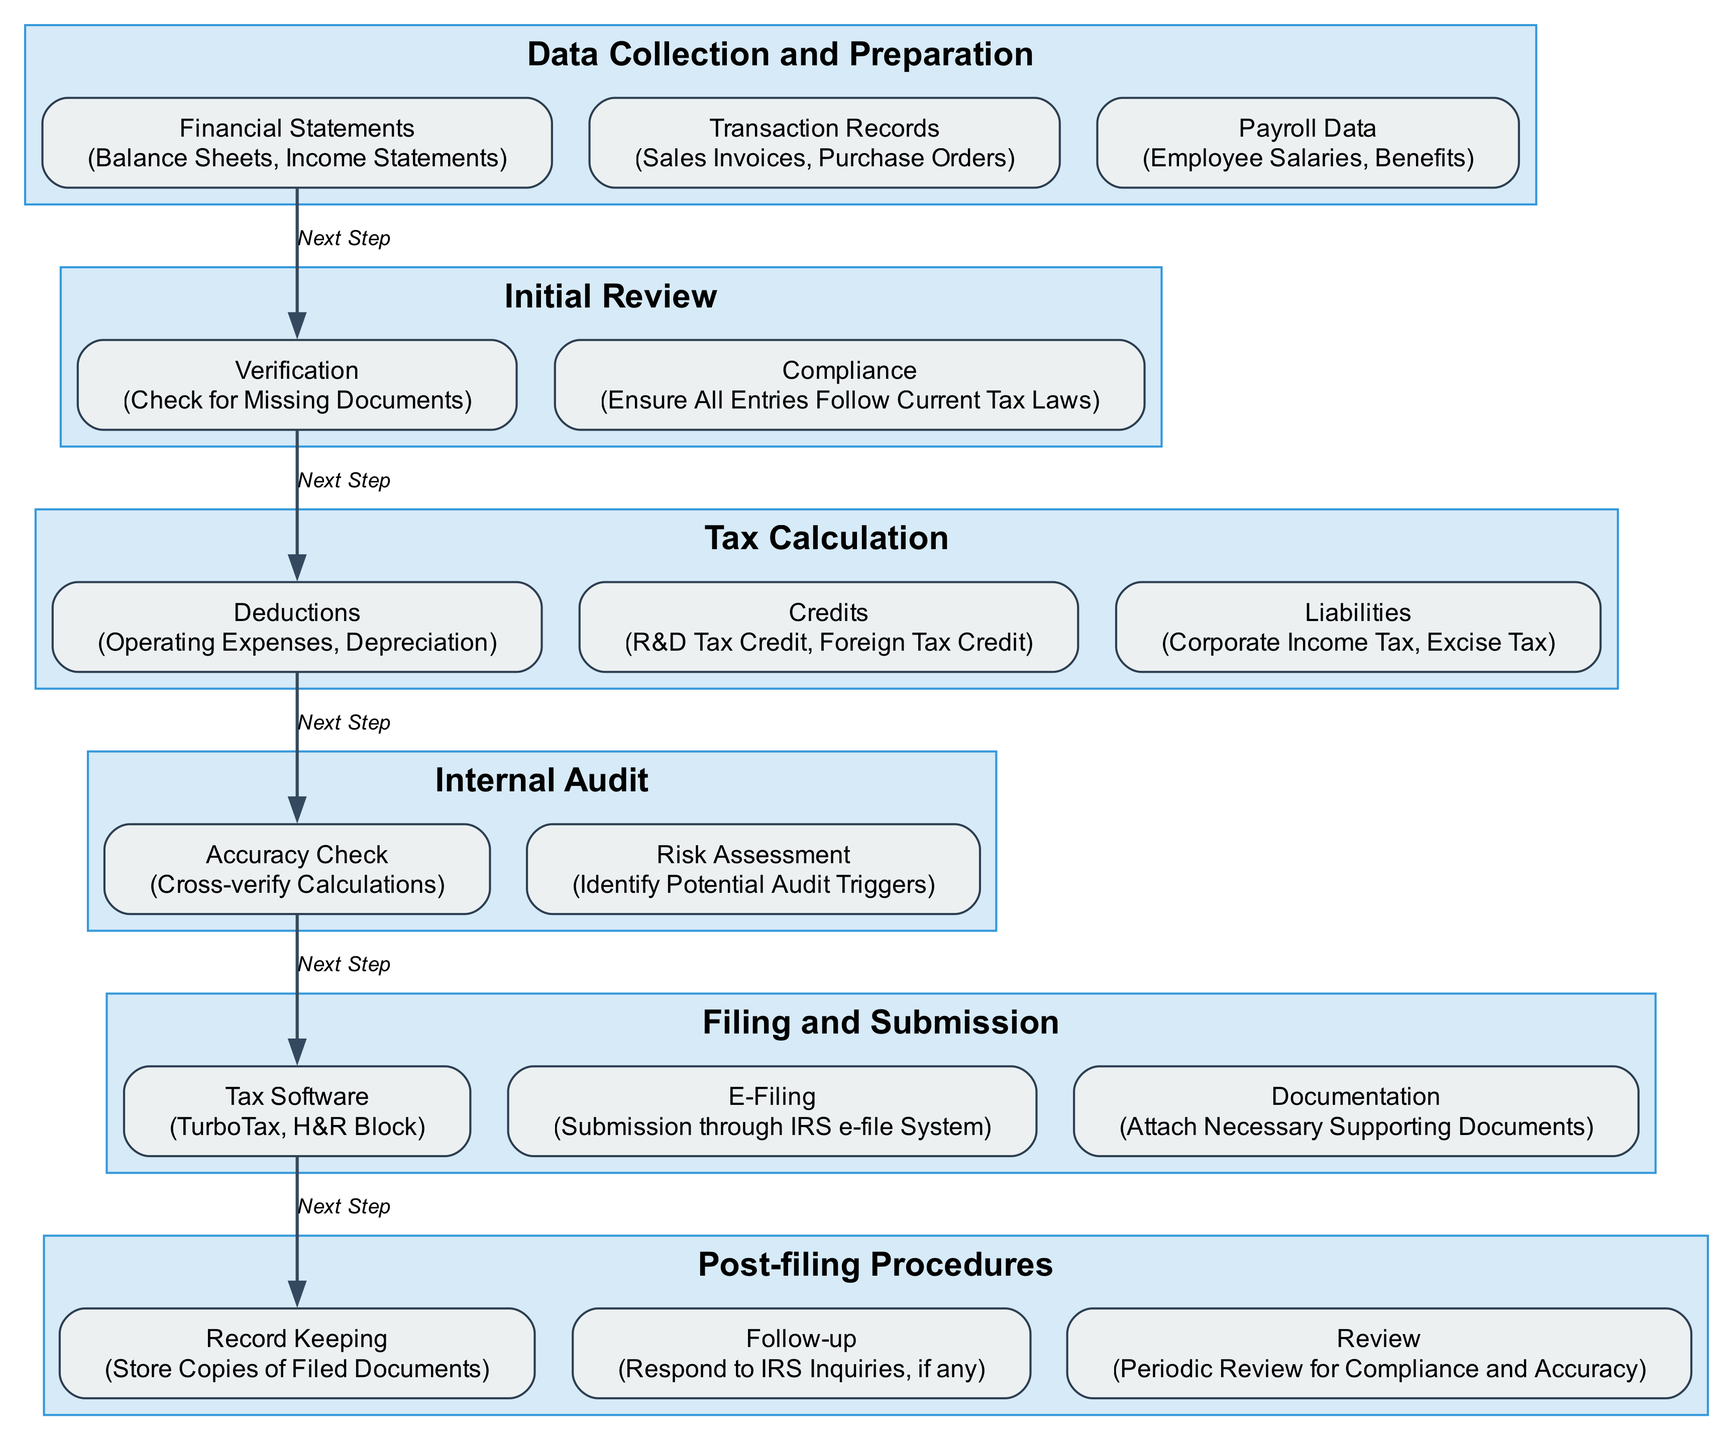What is the first step in the corporate tax filing process? The first step in the diagram is labeled "Data Collection and Preparation," which is prominently positioned at the top of the block diagram.
Answer: Data Collection and Preparation How many main steps are there in the corporate tax filing process? Counting the main steps listed in the diagram, there are six main processes indicated: Data Collection and Preparation, Initial Review, Tax Calculation, Internal Audit, Filing and Submission, and Post-filing Procedures.
Answer: 6 What is the second sub-step under "Initial Review"? Upon examining the "Initial Review" block, the two sub-steps are "Verification" and "Compliance," with "Compliance" being the second sub-step listed.
Answer: Compliance Which step follows "Tax Calculation"? By evaluating the flow of the diagram, "Internal Audit" comes immediately after "Tax Calculation," as indicated by the connecting edge labeled 'Next Step.'
Answer: Internal Audit What type of software is mentioned in the "Filing and Submission" step? The "Filing and Submission" block includes a sub-step for "Tax Software," specifically mentioning TurboTax and H&R Block as examples for this type of software.
Answer: TurboTax, H&R Block What is the main purpose of the "Post-filing Procedures"? The diagram indicates that the "Post-filing Procedures" includes activities such as record keeping, follow-ups with the IRS, and periodic reviews, suggesting that the main purpose is to ensure compliance and address any inquiries.
Answer: Compliance and inquiries What are the two components listed under "Tax Calculation" related to tax advantages? Within the "Tax Calculation" section, the components that provide tax advantages are "Credits," specifically mentioning R&D Tax Credit and Foreign Tax Credit, highlighting the potential benefits during tax calculations.
Answer: R&D Tax Credit, Foreign Tax Credit Which main step contains the element "Check for Missing Documents"? The element "Check for Missing Documents" is located in the "Initial Review" section of the diagram, indicating that this activity is part of ensuring a complete and accurate filing before progressing.
Answer: Initial Review What connects the "Filing and Submission" step to the "Post-filing Procedures"? The connection from "Filing and Submission" to "Post-filing Procedures" is made via a labeled edge indicating 'Next Step,' which illustrates the sequence of actions during the tax filing process.
Answer: Next Step 